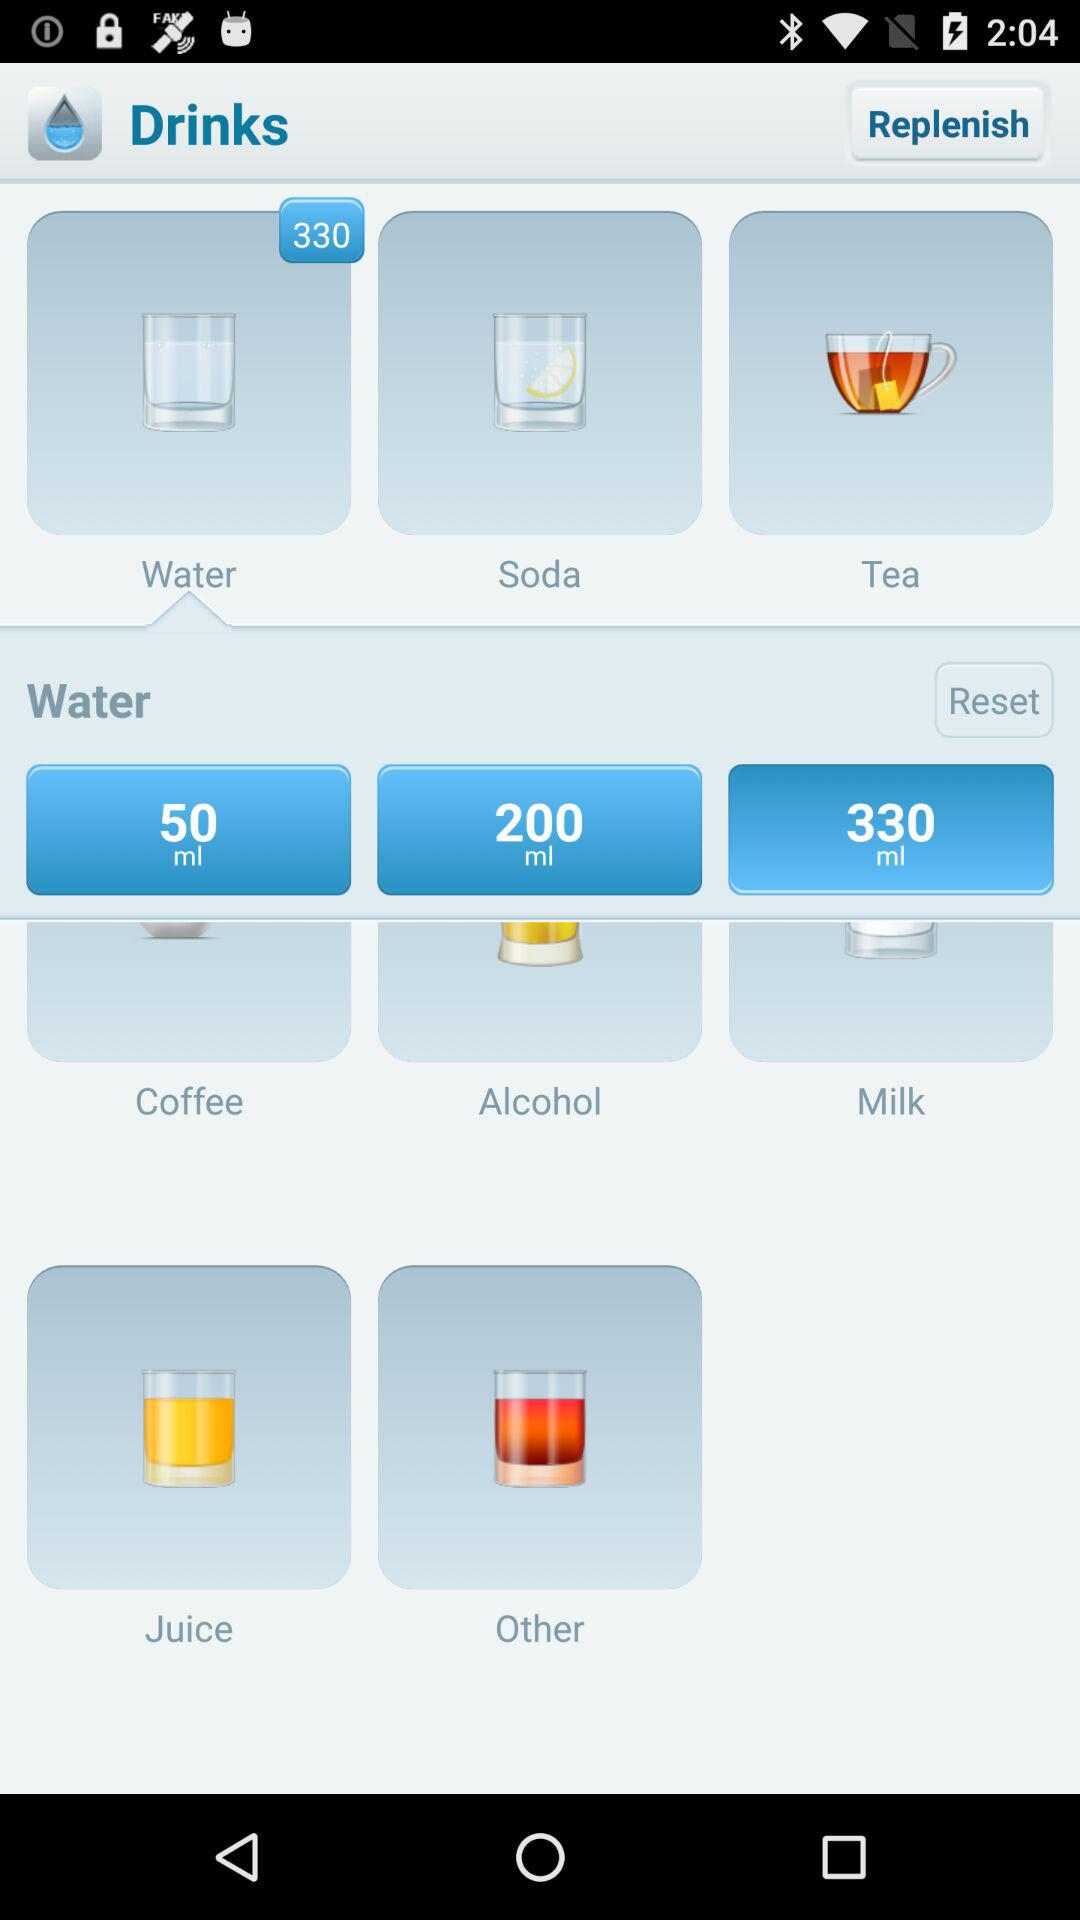What is the quantity of alcohol? The quantity of alcohol is 200 ml. 